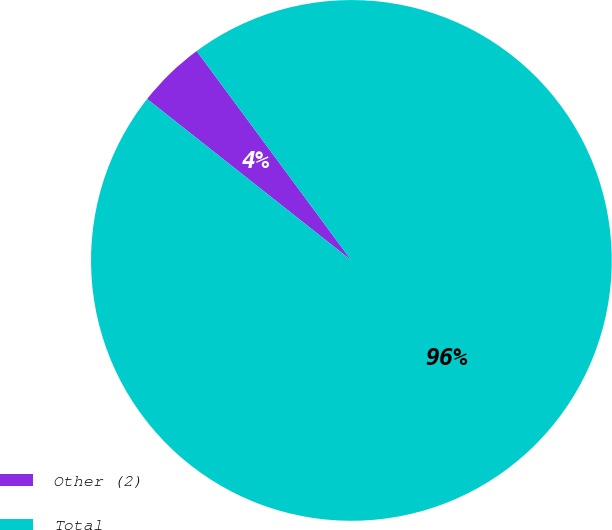Convert chart. <chart><loc_0><loc_0><loc_500><loc_500><pie_chart><fcel>Other (2)<fcel>Total<nl><fcel>4.23%<fcel>95.77%<nl></chart> 